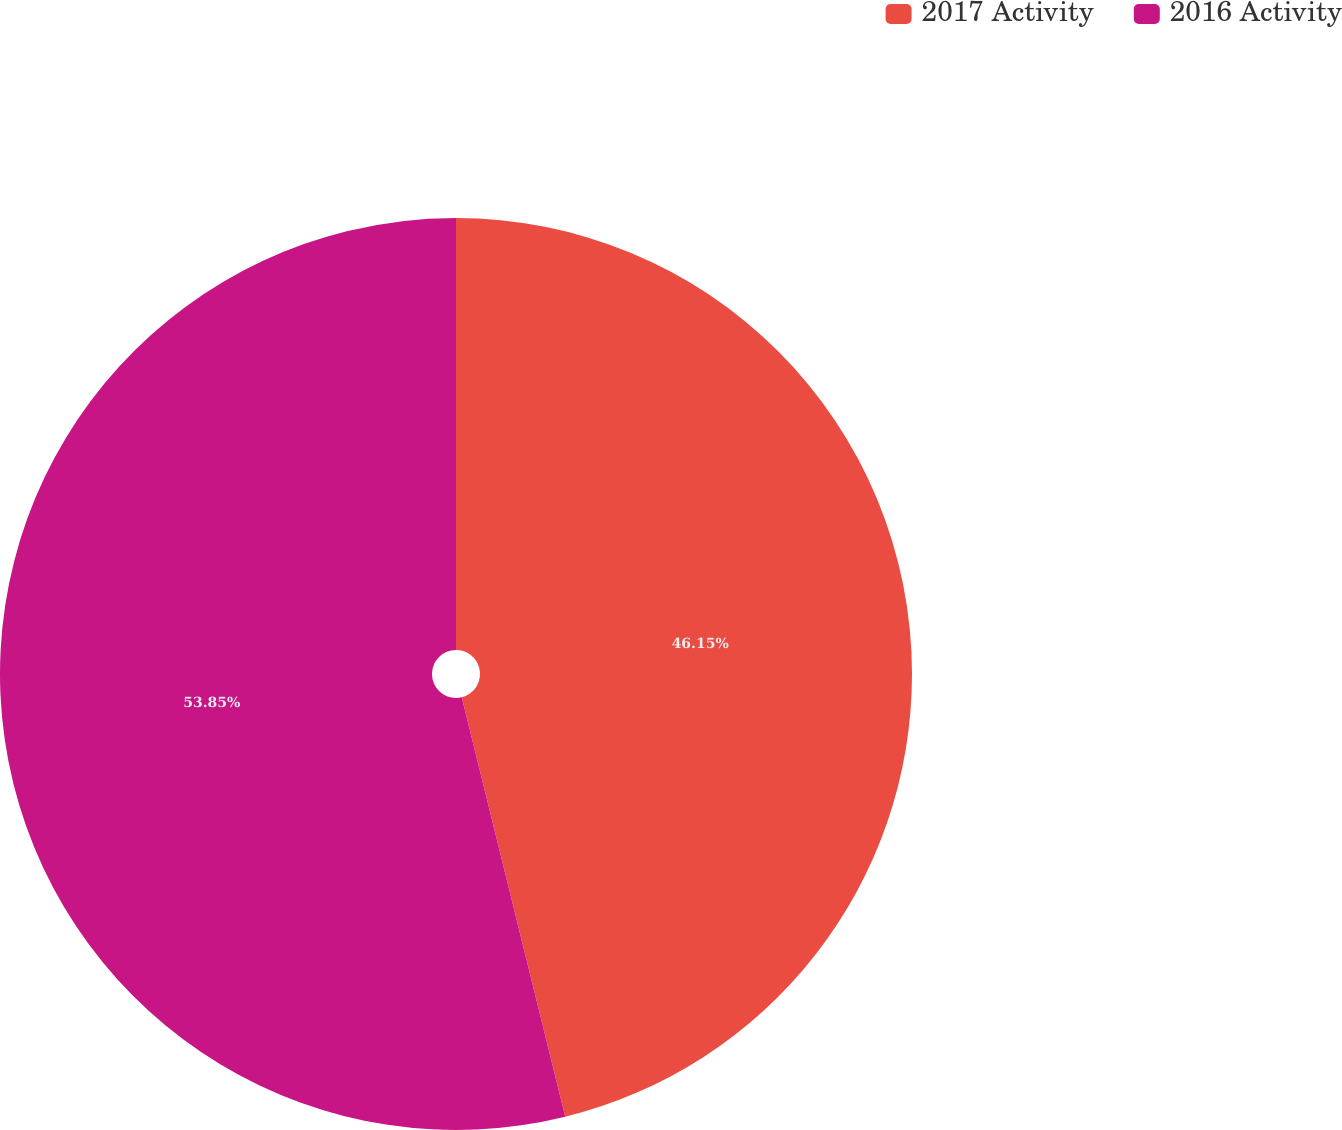Convert chart to OTSL. <chart><loc_0><loc_0><loc_500><loc_500><pie_chart><fcel>2017 Activity<fcel>2016 Activity<nl><fcel>46.15%<fcel>53.85%<nl></chart> 